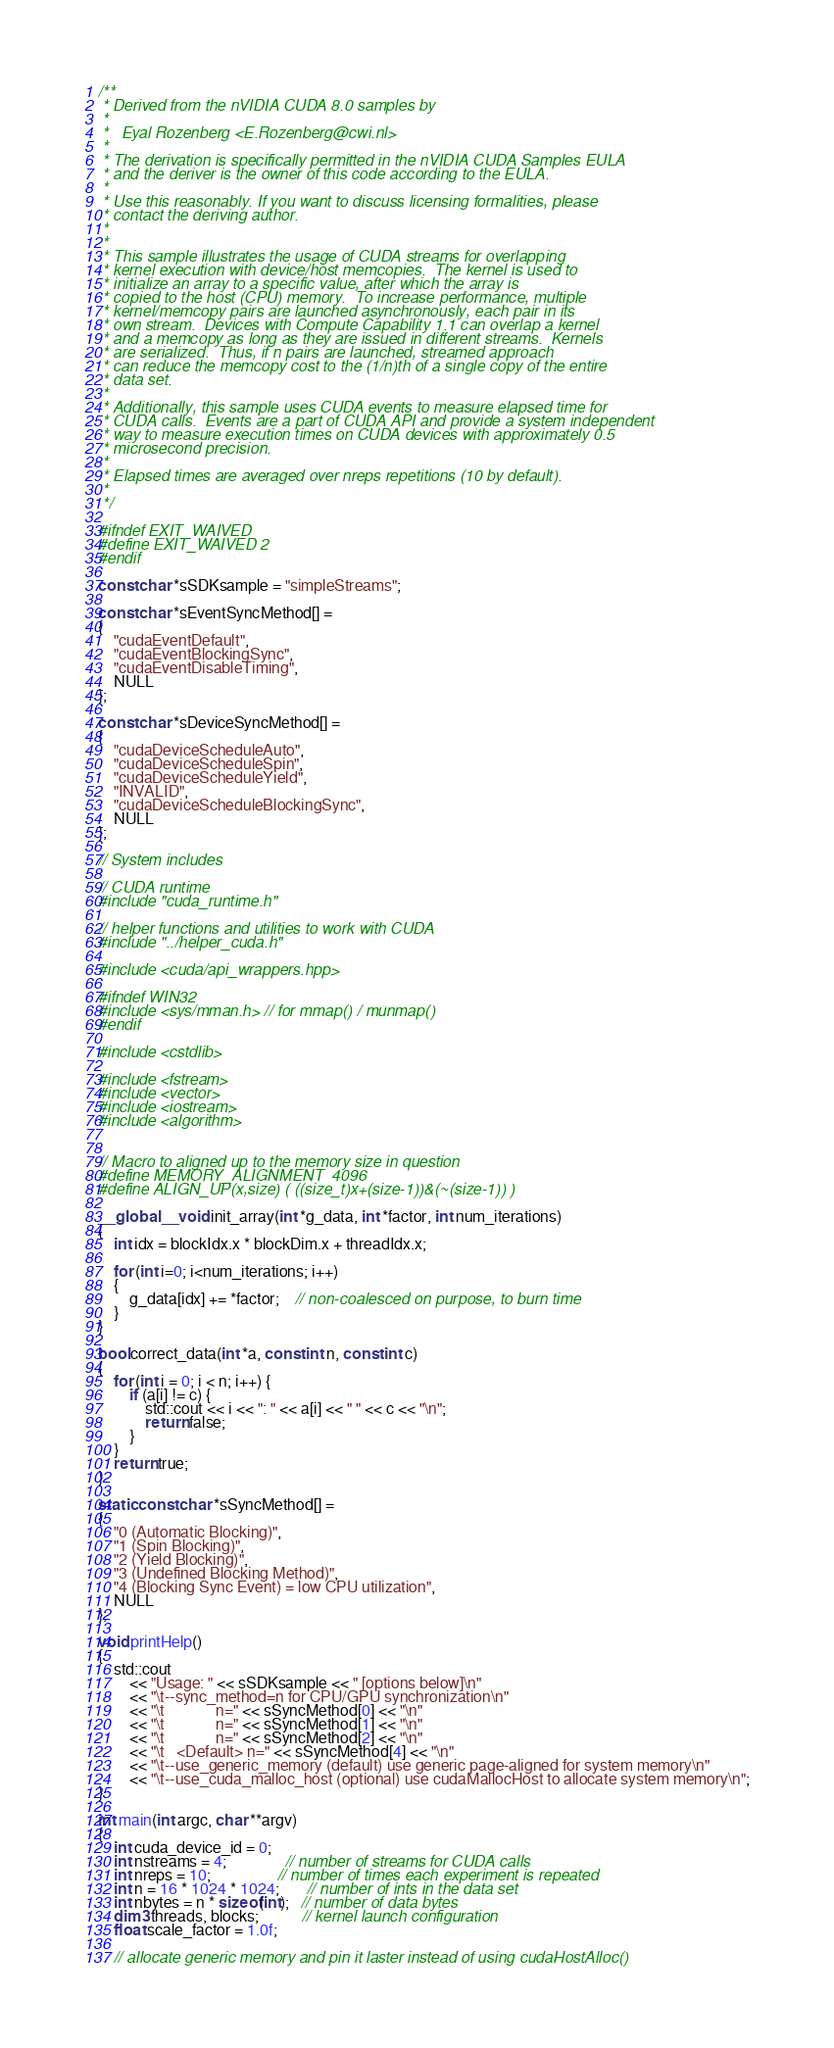<code> <loc_0><loc_0><loc_500><loc_500><_Cuda_>/**
 * Derived from the nVIDIA CUDA 8.0 samples by
 *
 *   Eyal Rozenberg <E.Rozenberg@cwi.nl>
 *
 * The derivation is specifically permitted in the nVIDIA CUDA Samples EULA
 * and the deriver is the owner of this code according to the EULA.
 *
 * Use this reasonably. If you want to discuss licensing formalities, please
 * contact the deriving author.
 *
 *
 * This sample illustrates the usage of CUDA streams for overlapping
 * kernel execution with device/host memcopies.  The kernel is used to
 * initialize an array to a specific value, after which the array is
 * copied to the host (CPU) memory.  To increase performance, multiple
 * kernel/memcopy pairs are launched asynchronously, each pair in its
 * own stream.  Devices with Compute Capability 1.1 can overlap a kernel
 * and a memcopy as long as they are issued in different streams.  Kernels
 * are serialized.  Thus, if n pairs are launched, streamed approach
 * can reduce the memcopy cost to the (1/n)th of a single copy of the entire
 * data set.
 *
 * Additionally, this sample uses CUDA events to measure elapsed time for
 * CUDA calls.  Events are a part of CUDA API and provide a system independent
 * way to measure execution times on CUDA devices with approximately 0.5
 * microsecond precision.
 *
 * Elapsed times are averaged over nreps repetitions (10 by default).
 *
 */

#ifndef EXIT_WAIVED
#define EXIT_WAIVED 2
#endif

const char *sSDKsample = "simpleStreams";

const char *sEventSyncMethod[] =
{
	"cudaEventDefault",
	"cudaEventBlockingSync",
	"cudaEventDisableTiming",
	NULL
};

const char *sDeviceSyncMethod[] =
{
	"cudaDeviceScheduleAuto",
	"cudaDeviceScheduleSpin",
	"cudaDeviceScheduleYield",
	"INVALID",
	"cudaDeviceScheduleBlockingSync",
	NULL
};

// System includes

// CUDA runtime
#include "cuda_runtime.h"

// helper functions and utilities to work with CUDA
#include "../helper_cuda.h"

#include <cuda/api_wrappers.hpp>

#ifndef WIN32
#include <sys/mman.h> // for mmap() / munmap()
#endif

#include <cstdlib>

#include <fstream>
#include <vector>
#include <iostream>
#include <algorithm>


// Macro to aligned up to the memory size in question
#define MEMORY_ALIGNMENT  4096
#define ALIGN_UP(x,size) ( ((size_t)x+(size-1))&(~(size-1)) )

__global__ void init_array(int *g_data, int *factor, int num_iterations)
{
	int idx = blockIdx.x * blockDim.x + threadIdx.x;

	for (int i=0; i<num_iterations; i++)
	{
		g_data[idx] += *factor;    // non-coalesced on purpose, to burn time
	}
}

bool correct_data(int *a, const int n, const int c)
{
	for (int i = 0; i < n; i++) {
		if (a[i] != c) {
			std::cout << i << ": " << a[i] << " " << c << "\n";
			return false;
		}
	}
	return true;
}

static const char *sSyncMethod[] =
{
	"0 (Automatic Blocking)",
	"1 (Spin Blocking)",
	"2 (Yield Blocking)",
	"3 (Undefined Blocking Method)",
	"4 (Blocking Sync Event) = low CPU utilization",
	NULL
};

void printHelp()
{
	std::cout
		<< "Usage: " << sSDKsample << " [options below]\n"
		<< "\t--sync_method=n for CPU/GPU synchronization\n"
		<< "\t             n=" << sSyncMethod[0] << "\n"
		<< "\t             n=" << sSyncMethod[1] << "\n"
		<< "\t             n=" << sSyncMethod[2] << "\n"
		<< "\t   <Default> n=" << sSyncMethod[4] << "\n"
		<< "\t--use_generic_memory (default) use generic page-aligned for system memory\n"
		<< "\t--use_cuda_malloc_host (optional) use cudaMallocHost to allocate system memory\n";
}

int main(int argc, char **argv)
{
	int cuda_device_id = 0;
	int nstreams = 4;               // number of streams for CUDA calls
	int nreps = 10;                 // number of times each experiment is repeated
	int n = 16 * 1024 * 1024;       // number of ints in the data set
	int nbytes = n * sizeof(int);   // number of data bytes
	dim3 threads, blocks;           // kernel launch configuration
	float scale_factor = 1.0f;

	// allocate generic memory and pin it laster instead of using cudaHostAlloc()
</code> 